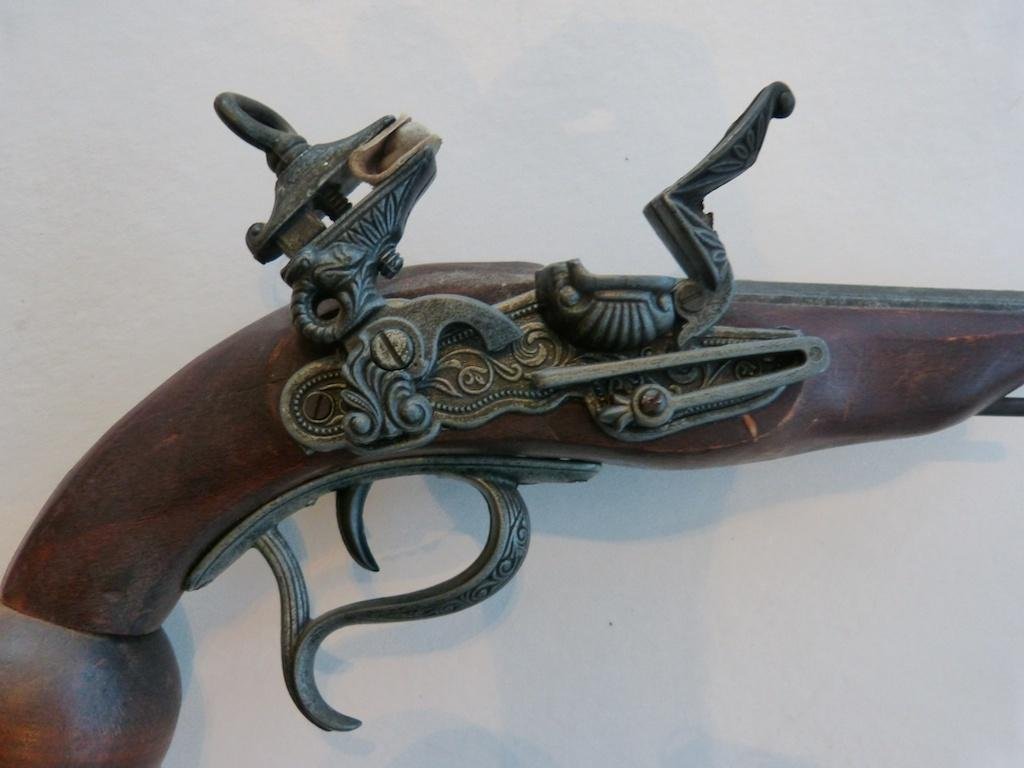What is the main object in the center of the image? There is a pistol in the center of the image. What is placed on the pistol? There is an iron sculpture on the pistol. What color is the background of the image? The image has a white background. What type of bun is being used to rub the pistol in the image? There is no bun or rubbing action present in the image; it only features a pistol with an iron sculpture on it against a white background. 